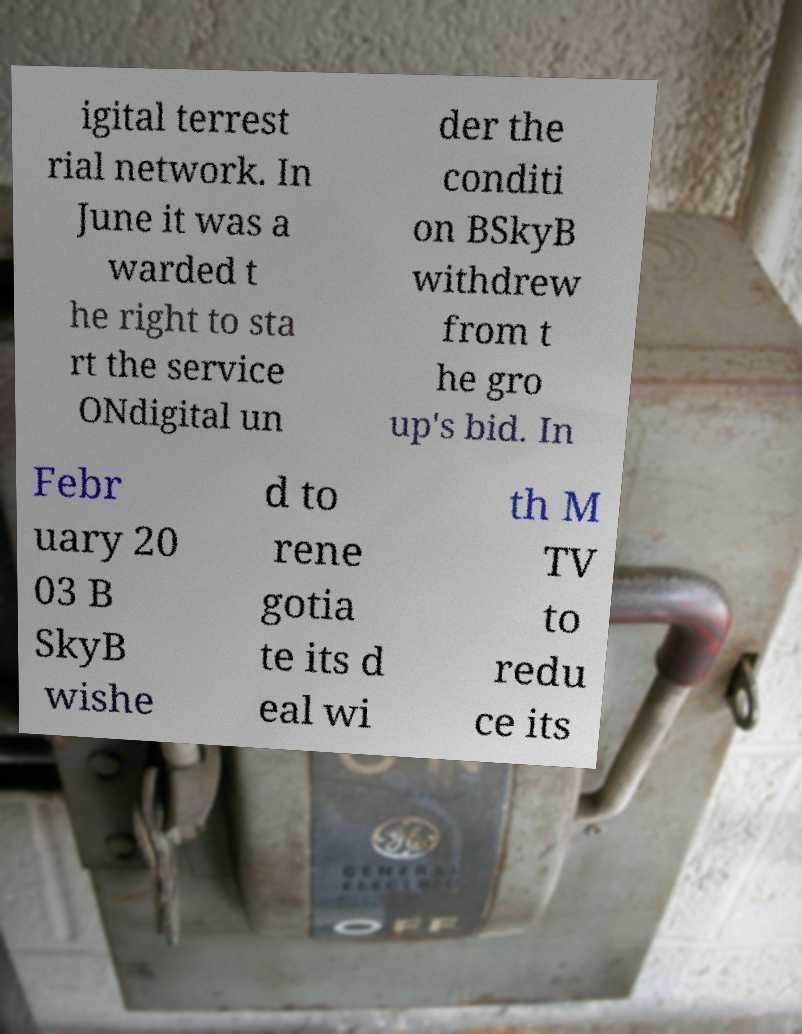Please identify and transcribe the text found in this image. igital terrest rial network. In June it was a warded t he right to sta rt the service ONdigital un der the conditi on BSkyB withdrew from t he gro up's bid. In Febr uary 20 03 B SkyB wishe d to rene gotia te its d eal wi th M TV to redu ce its 